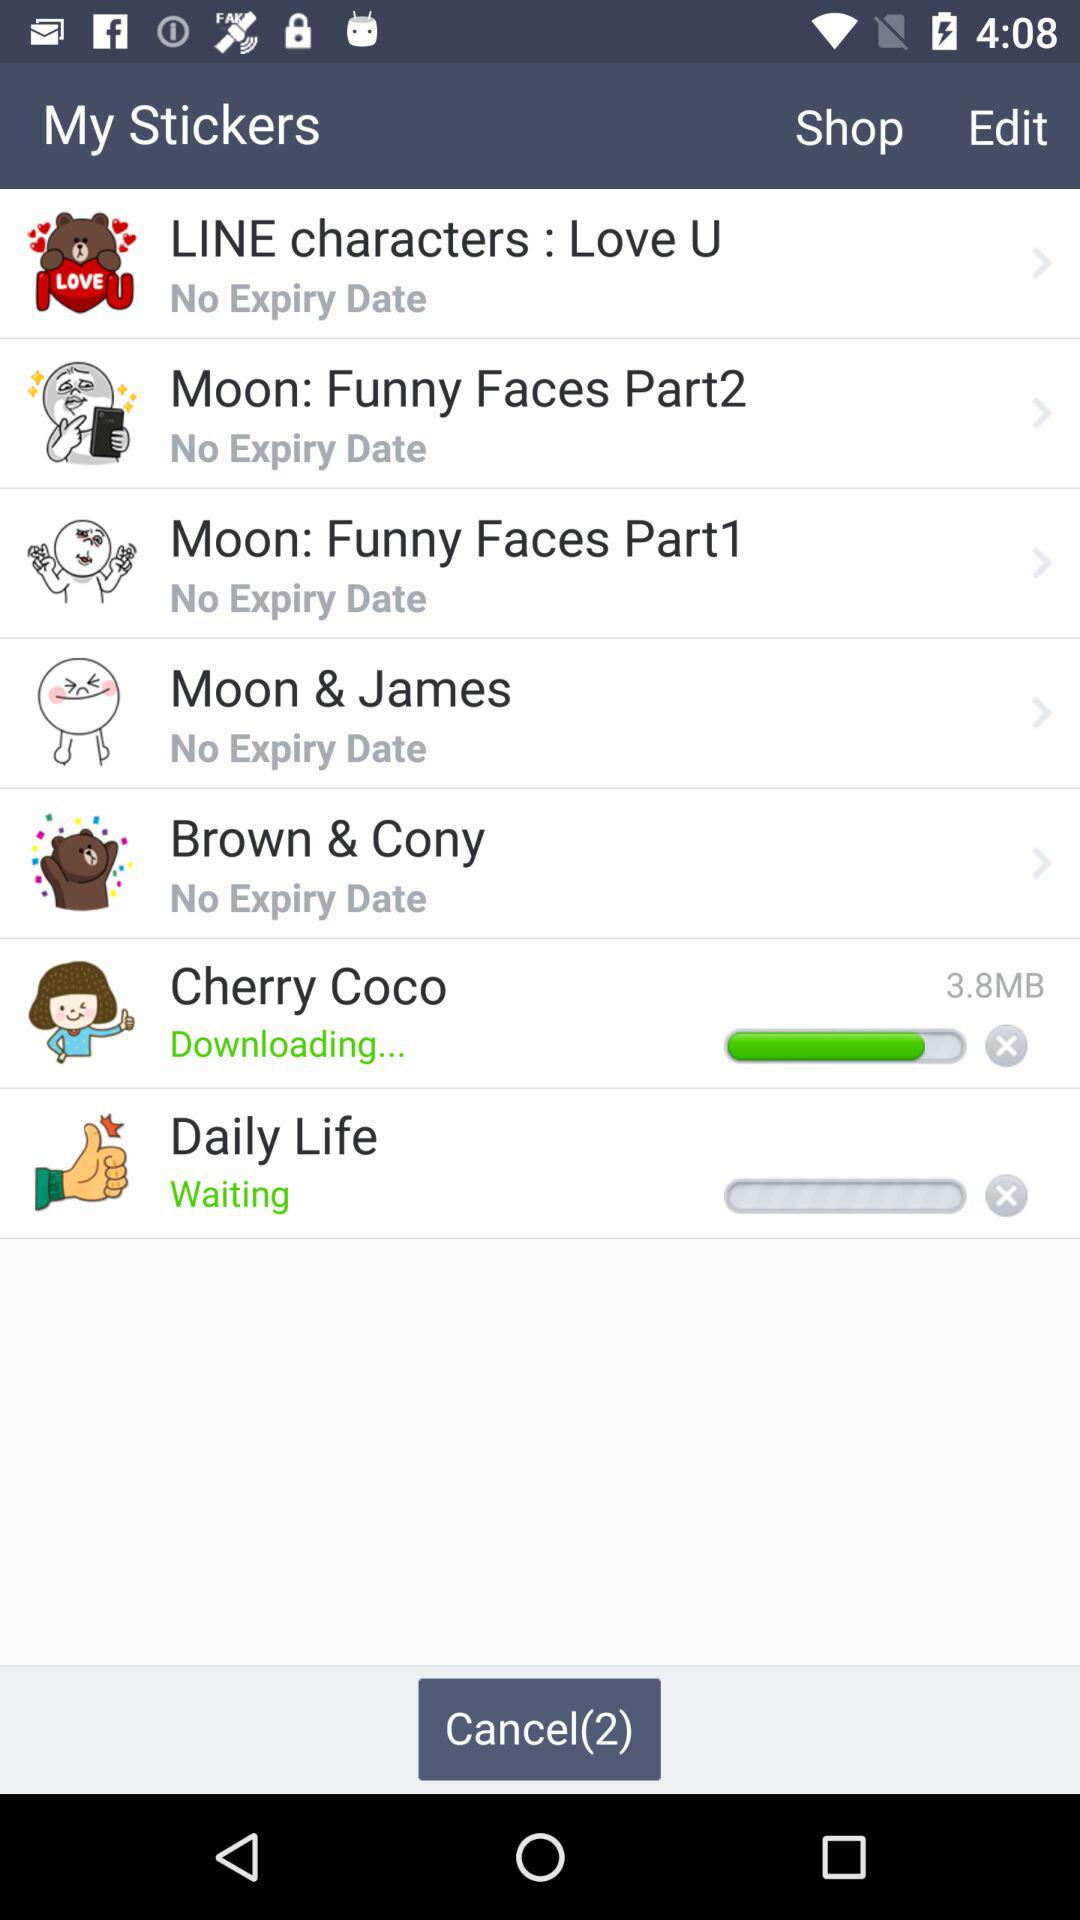What's the expiration date of the "Moon & James" sticker? There is no expiration date for the "Moon & James" sticker. 